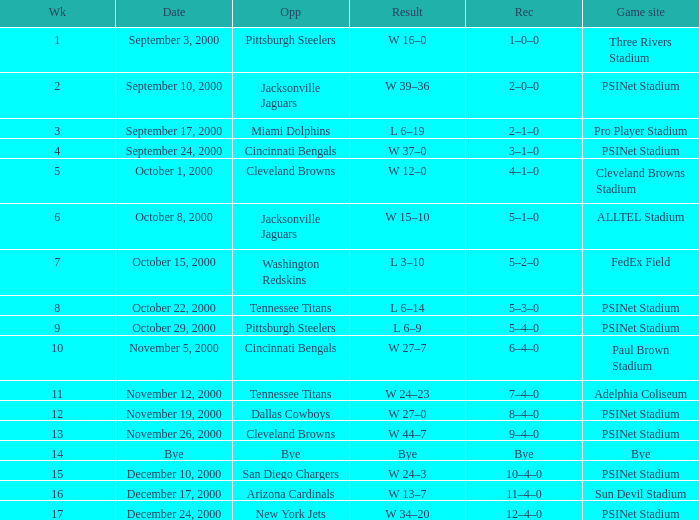What's the record for October 8, 2000 before week 13? 5–1–0. 